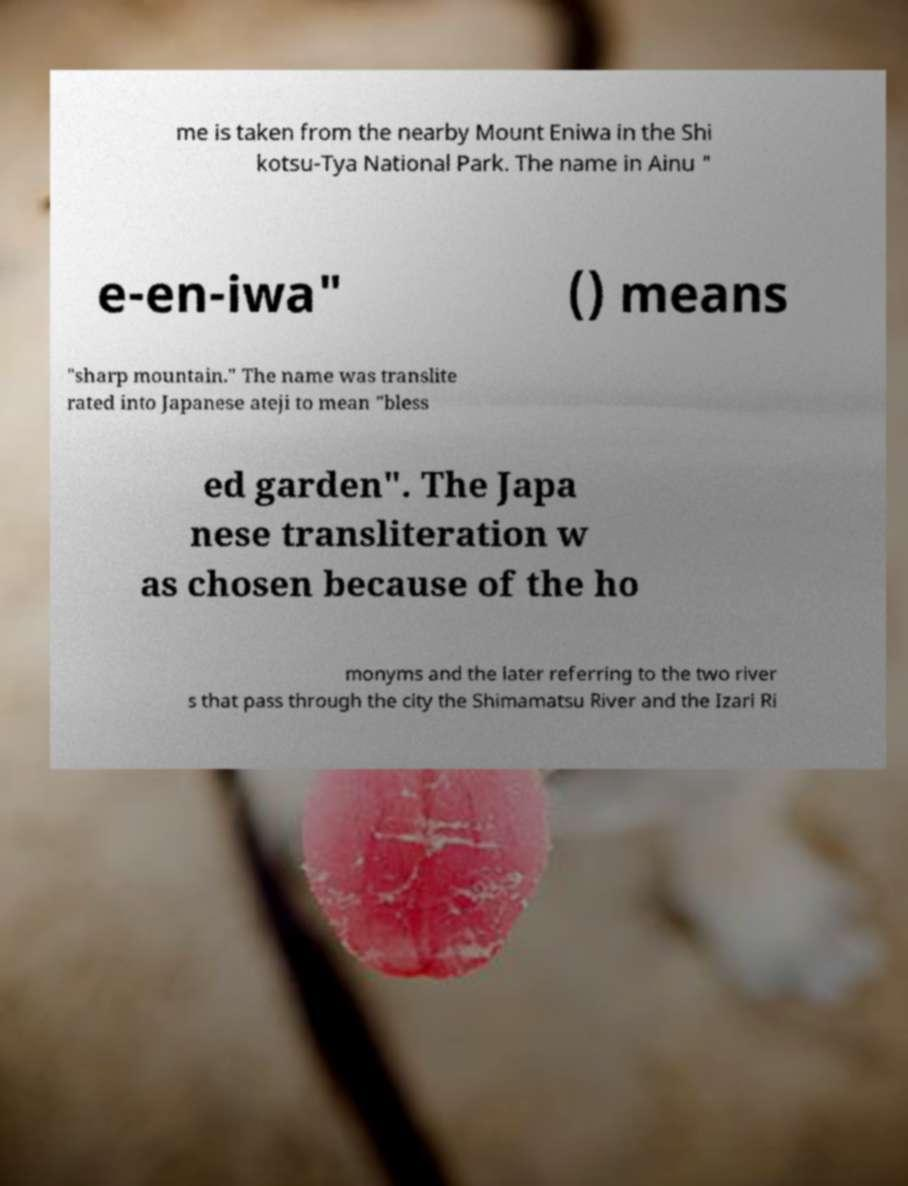Please read and relay the text visible in this image. What does it say? me is taken from the nearby Mount Eniwa in the Shi kotsu-Tya National Park. The name in Ainu " e-en-iwa" () means "sharp mountain." The name was translite rated into Japanese ateji to mean "bless ed garden". The Japa nese transliteration w as chosen because of the ho monyms and the later referring to the two river s that pass through the city the Shimamatsu River and the Izari Ri 